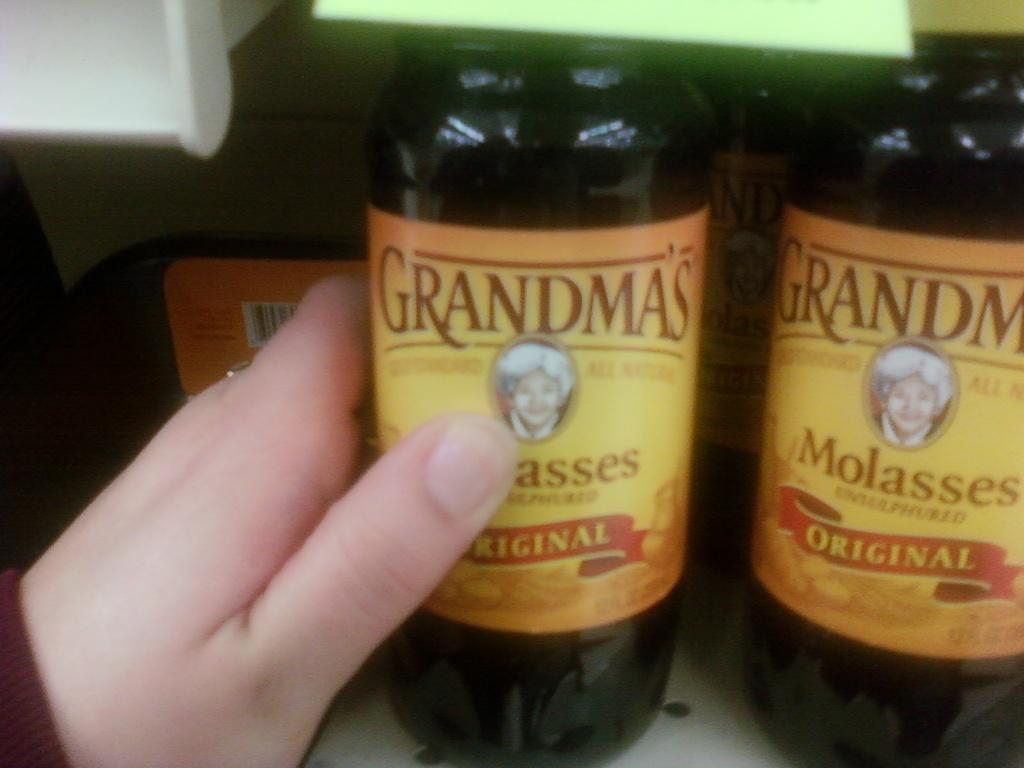What brand of molasses?
Offer a terse response. Grandma's. 